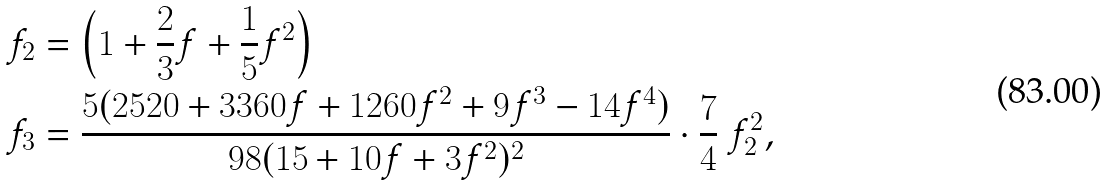<formula> <loc_0><loc_0><loc_500><loc_500>f _ { 2 } & = \left ( 1 + \frac { 2 } { 3 } f + \frac { 1 } { 5 } f ^ { 2 } \right ) \\ f _ { 3 } & = \frac { 5 ( 2 5 2 0 + 3 3 6 0 f + 1 2 6 0 f ^ { 2 } + 9 f ^ { 3 } - 1 4 f ^ { 4 } ) } { 9 8 ( 1 5 + 1 0 f + 3 f ^ { 2 } ) ^ { 2 } } \cdot \frac { 7 } { 4 } \ f _ { 2 } ^ { 2 } ,</formula> 